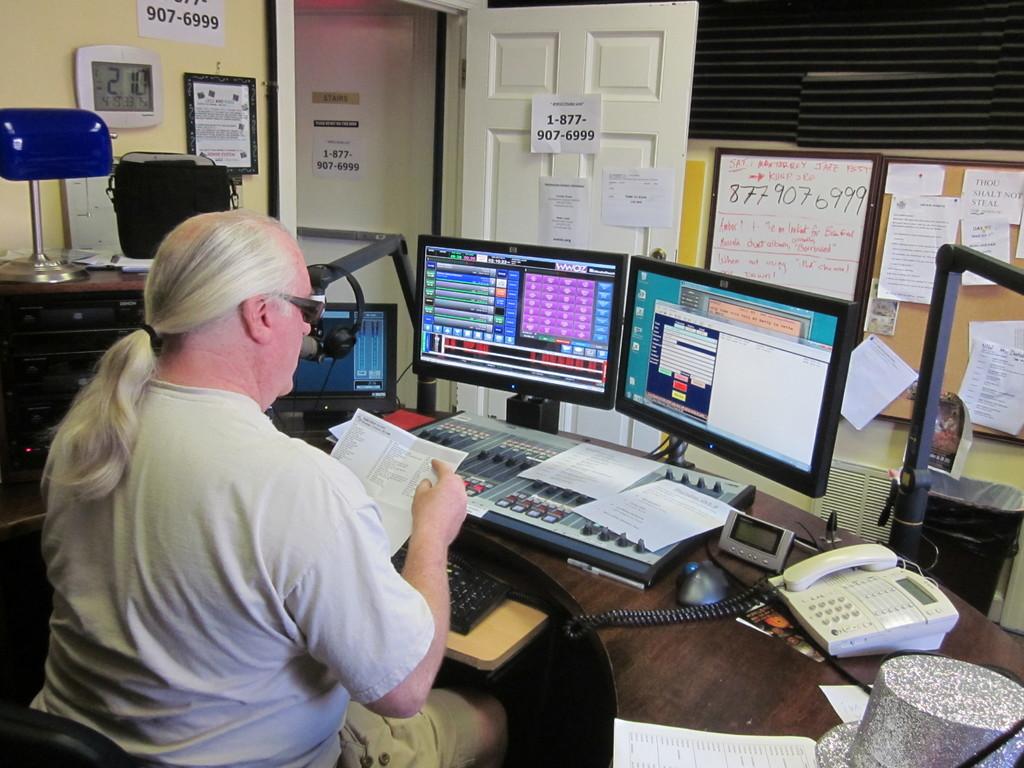This is computer?
Your answer should be compact. Yes. 